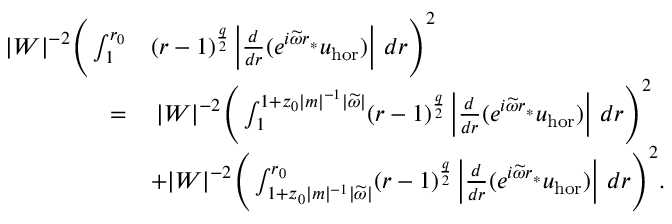Convert formula to latex. <formula><loc_0><loc_0><loc_500><loc_500>\begin{array} { r l } { | W | ^ { - 2 } \left ( \int _ { 1 } ^ { r _ { 0 } } } & { ( r - 1 ) ^ { \frac { q } { 2 } } \left | \frac { d } { d r } ( e ^ { i \widetilde { \omega } r _ { * } } { u } _ { h o r } ) \right | \, d r \right ) ^ { 2 } } \\ { = } & { \, | W | ^ { - 2 } \left ( \int _ { 1 } ^ { 1 + z _ { 0 } | m | ^ { - 1 } | \widetilde { \omega } | } ( r - 1 ) ^ { \frac { q } { 2 } } \left | \frac { d } { d r } ( e ^ { i \widetilde { \omega } r _ { * } } { u } _ { h o r } ) \right | \, d r \right ) ^ { 2 } } \\ & { + | W | ^ { - 2 } \left ( \int _ { 1 + z _ { 0 } | m | ^ { - 1 } | \widetilde { \omega } | } ^ { r _ { 0 } } ( r - 1 ) ^ { \frac { q } { 2 } } \left | \frac { d } { d r } ( e ^ { i \widetilde { \omega } r _ { * } } u _ { h o r } ) \right | \, d r \right ) ^ { 2 } . } \end{array}</formula> 